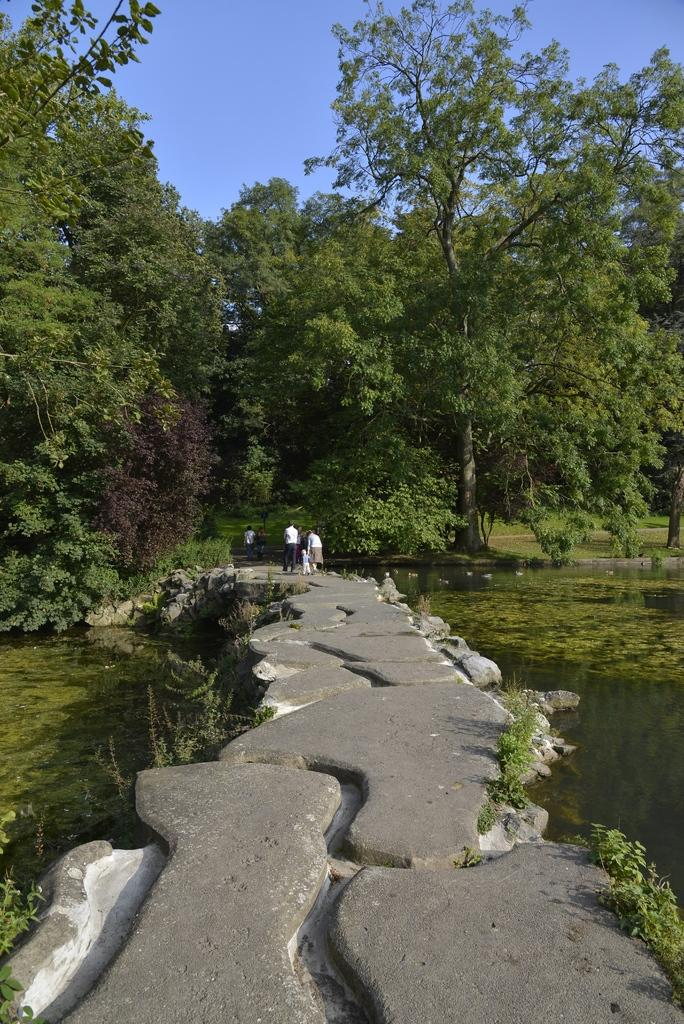What is the main feature of the image? There is a path or way in the image. What can be seen on either side of the path? There are trees and water on either side of the path. Can you describe the background of the image? There are people in the background of the image. What type of thread is being used to weave the plants in the image? There is no thread or weaving of plants present in the image. 